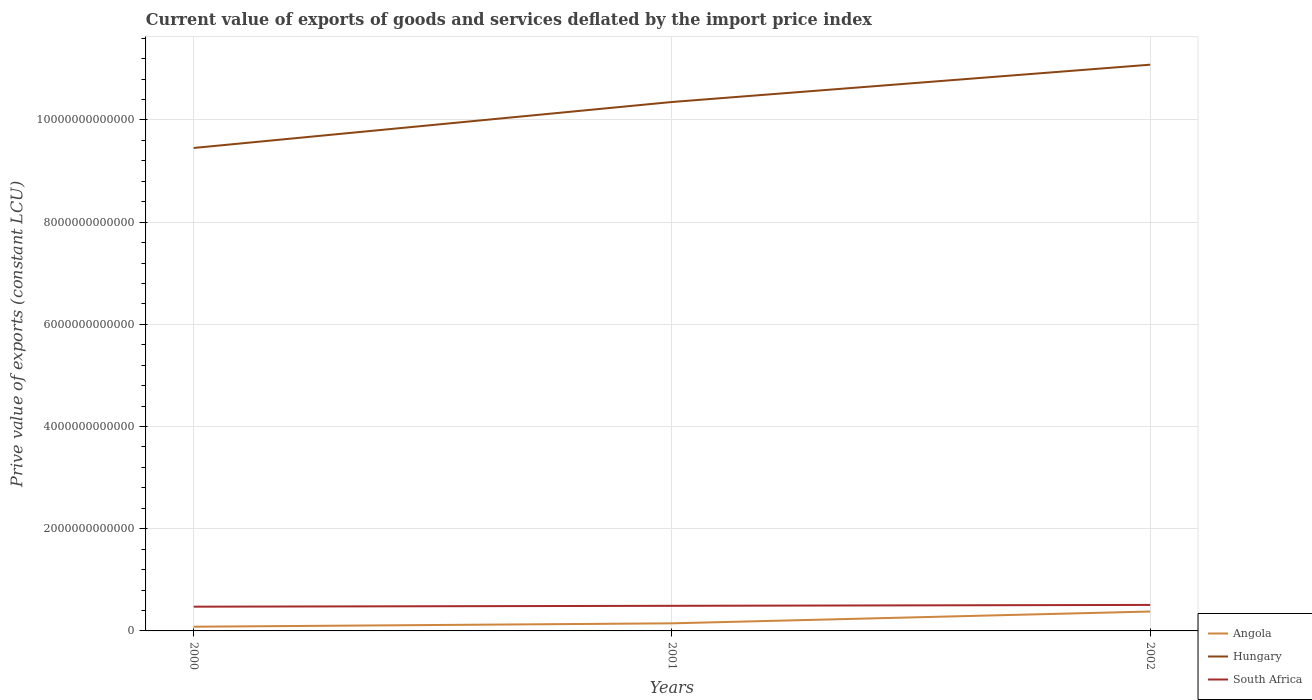Does the line corresponding to Angola intersect with the line corresponding to South Africa?
Your answer should be compact. No. Is the number of lines equal to the number of legend labels?
Give a very brief answer. Yes. Across all years, what is the maximum prive value of exports in Angola?
Your response must be concise. 8.22e+1. In which year was the prive value of exports in Hungary maximum?
Offer a very short reply. 2000. What is the total prive value of exports in Hungary in the graph?
Your answer should be very brief. -7.30e+11. What is the difference between the highest and the second highest prive value of exports in Angola?
Your answer should be compact. 2.98e+11. What is the difference between the highest and the lowest prive value of exports in Hungary?
Provide a succinct answer. 2. Is the prive value of exports in South Africa strictly greater than the prive value of exports in Hungary over the years?
Your response must be concise. Yes. How many lines are there?
Make the answer very short. 3. How many years are there in the graph?
Keep it short and to the point. 3. What is the difference between two consecutive major ticks on the Y-axis?
Give a very brief answer. 2.00e+12. Are the values on the major ticks of Y-axis written in scientific E-notation?
Your answer should be compact. No. Does the graph contain grids?
Offer a very short reply. Yes. Where does the legend appear in the graph?
Your answer should be very brief. Bottom right. How are the legend labels stacked?
Your response must be concise. Vertical. What is the title of the graph?
Your answer should be very brief. Current value of exports of goods and services deflated by the import price index. Does "Jordan" appear as one of the legend labels in the graph?
Your response must be concise. No. What is the label or title of the Y-axis?
Make the answer very short. Prive value of exports (constant LCU). What is the Prive value of exports (constant LCU) of Angola in 2000?
Your response must be concise. 8.22e+1. What is the Prive value of exports (constant LCU) in Hungary in 2000?
Make the answer very short. 9.45e+12. What is the Prive value of exports (constant LCU) in South Africa in 2000?
Make the answer very short. 4.75e+11. What is the Prive value of exports (constant LCU) in Angola in 2001?
Offer a very short reply. 1.49e+11. What is the Prive value of exports (constant LCU) in Hungary in 2001?
Give a very brief answer. 1.04e+13. What is the Prive value of exports (constant LCU) in South Africa in 2001?
Provide a succinct answer. 4.91e+11. What is the Prive value of exports (constant LCU) in Angola in 2002?
Offer a terse response. 3.80e+11. What is the Prive value of exports (constant LCU) in Hungary in 2002?
Ensure brevity in your answer.  1.11e+13. What is the Prive value of exports (constant LCU) of South Africa in 2002?
Your answer should be very brief. 5.09e+11. Across all years, what is the maximum Prive value of exports (constant LCU) in Angola?
Ensure brevity in your answer.  3.80e+11. Across all years, what is the maximum Prive value of exports (constant LCU) in Hungary?
Your answer should be compact. 1.11e+13. Across all years, what is the maximum Prive value of exports (constant LCU) in South Africa?
Your answer should be compact. 5.09e+11. Across all years, what is the minimum Prive value of exports (constant LCU) of Angola?
Your answer should be very brief. 8.22e+1. Across all years, what is the minimum Prive value of exports (constant LCU) in Hungary?
Offer a very short reply. 9.45e+12. Across all years, what is the minimum Prive value of exports (constant LCU) of South Africa?
Keep it short and to the point. 4.75e+11. What is the total Prive value of exports (constant LCU) of Angola in the graph?
Provide a short and direct response. 6.11e+11. What is the total Prive value of exports (constant LCU) of Hungary in the graph?
Provide a succinct answer. 3.09e+13. What is the total Prive value of exports (constant LCU) of South Africa in the graph?
Keep it short and to the point. 1.47e+12. What is the difference between the Prive value of exports (constant LCU) in Angola in 2000 and that in 2001?
Provide a short and direct response. -6.64e+1. What is the difference between the Prive value of exports (constant LCU) in Hungary in 2000 and that in 2001?
Your answer should be very brief. -9.00e+11. What is the difference between the Prive value of exports (constant LCU) in South Africa in 2000 and that in 2001?
Make the answer very short. -1.68e+1. What is the difference between the Prive value of exports (constant LCU) in Angola in 2000 and that in 2002?
Your answer should be compact. -2.98e+11. What is the difference between the Prive value of exports (constant LCU) in Hungary in 2000 and that in 2002?
Give a very brief answer. -1.63e+12. What is the difference between the Prive value of exports (constant LCU) of South Africa in 2000 and that in 2002?
Ensure brevity in your answer.  -3.42e+1. What is the difference between the Prive value of exports (constant LCU) of Angola in 2001 and that in 2002?
Ensure brevity in your answer.  -2.31e+11. What is the difference between the Prive value of exports (constant LCU) of Hungary in 2001 and that in 2002?
Provide a succinct answer. -7.30e+11. What is the difference between the Prive value of exports (constant LCU) in South Africa in 2001 and that in 2002?
Offer a very short reply. -1.75e+1. What is the difference between the Prive value of exports (constant LCU) of Angola in 2000 and the Prive value of exports (constant LCU) of Hungary in 2001?
Give a very brief answer. -1.03e+13. What is the difference between the Prive value of exports (constant LCU) in Angola in 2000 and the Prive value of exports (constant LCU) in South Africa in 2001?
Make the answer very short. -4.09e+11. What is the difference between the Prive value of exports (constant LCU) of Hungary in 2000 and the Prive value of exports (constant LCU) of South Africa in 2001?
Offer a very short reply. 8.96e+12. What is the difference between the Prive value of exports (constant LCU) of Angola in 2000 and the Prive value of exports (constant LCU) of Hungary in 2002?
Ensure brevity in your answer.  -1.10e+13. What is the difference between the Prive value of exports (constant LCU) in Angola in 2000 and the Prive value of exports (constant LCU) in South Africa in 2002?
Make the answer very short. -4.27e+11. What is the difference between the Prive value of exports (constant LCU) of Hungary in 2000 and the Prive value of exports (constant LCU) of South Africa in 2002?
Make the answer very short. 8.94e+12. What is the difference between the Prive value of exports (constant LCU) in Angola in 2001 and the Prive value of exports (constant LCU) in Hungary in 2002?
Make the answer very short. -1.09e+13. What is the difference between the Prive value of exports (constant LCU) of Angola in 2001 and the Prive value of exports (constant LCU) of South Africa in 2002?
Offer a very short reply. -3.60e+11. What is the difference between the Prive value of exports (constant LCU) of Hungary in 2001 and the Prive value of exports (constant LCU) of South Africa in 2002?
Offer a very short reply. 9.84e+12. What is the average Prive value of exports (constant LCU) in Angola per year?
Provide a short and direct response. 2.04e+11. What is the average Prive value of exports (constant LCU) in Hungary per year?
Your response must be concise. 1.03e+13. What is the average Prive value of exports (constant LCU) of South Africa per year?
Provide a succinct answer. 4.92e+11. In the year 2000, what is the difference between the Prive value of exports (constant LCU) of Angola and Prive value of exports (constant LCU) of Hungary?
Your answer should be compact. -9.37e+12. In the year 2000, what is the difference between the Prive value of exports (constant LCU) in Angola and Prive value of exports (constant LCU) in South Africa?
Provide a short and direct response. -3.92e+11. In the year 2000, what is the difference between the Prive value of exports (constant LCU) of Hungary and Prive value of exports (constant LCU) of South Africa?
Provide a succinct answer. 8.98e+12. In the year 2001, what is the difference between the Prive value of exports (constant LCU) of Angola and Prive value of exports (constant LCU) of Hungary?
Make the answer very short. -1.02e+13. In the year 2001, what is the difference between the Prive value of exports (constant LCU) of Angola and Prive value of exports (constant LCU) of South Africa?
Keep it short and to the point. -3.43e+11. In the year 2001, what is the difference between the Prive value of exports (constant LCU) of Hungary and Prive value of exports (constant LCU) of South Africa?
Keep it short and to the point. 9.86e+12. In the year 2002, what is the difference between the Prive value of exports (constant LCU) of Angola and Prive value of exports (constant LCU) of Hungary?
Keep it short and to the point. -1.07e+13. In the year 2002, what is the difference between the Prive value of exports (constant LCU) in Angola and Prive value of exports (constant LCU) in South Africa?
Your response must be concise. -1.29e+11. In the year 2002, what is the difference between the Prive value of exports (constant LCU) in Hungary and Prive value of exports (constant LCU) in South Africa?
Keep it short and to the point. 1.06e+13. What is the ratio of the Prive value of exports (constant LCU) in Angola in 2000 to that in 2001?
Provide a short and direct response. 0.55. What is the ratio of the Prive value of exports (constant LCU) of Hungary in 2000 to that in 2001?
Ensure brevity in your answer.  0.91. What is the ratio of the Prive value of exports (constant LCU) in South Africa in 2000 to that in 2001?
Keep it short and to the point. 0.97. What is the ratio of the Prive value of exports (constant LCU) of Angola in 2000 to that in 2002?
Ensure brevity in your answer.  0.22. What is the ratio of the Prive value of exports (constant LCU) in Hungary in 2000 to that in 2002?
Make the answer very short. 0.85. What is the ratio of the Prive value of exports (constant LCU) of South Africa in 2000 to that in 2002?
Offer a terse response. 0.93. What is the ratio of the Prive value of exports (constant LCU) in Angola in 2001 to that in 2002?
Your response must be concise. 0.39. What is the ratio of the Prive value of exports (constant LCU) in Hungary in 2001 to that in 2002?
Ensure brevity in your answer.  0.93. What is the ratio of the Prive value of exports (constant LCU) in South Africa in 2001 to that in 2002?
Your answer should be very brief. 0.97. What is the difference between the highest and the second highest Prive value of exports (constant LCU) in Angola?
Your answer should be compact. 2.31e+11. What is the difference between the highest and the second highest Prive value of exports (constant LCU) of Hungary?
Provide a short and direct response. 7.30e+11. What is the difference between the highest and the second highest Prive value of exports (constant LCU) of South Africa?
Make the answer very short. 1.75e+1. What is the difference between the highest and the lowest Prive value of exports (constant LCU) of Angola?
Provide a succinct answer. 2.98e+11. What is the difference between the highest and the lowest Prive value of exports (constant LCU) in Hungary?
Your answer should be very brief. 1.63e+12. What is the difference between the highest and the lowest Prive value of exports (constant LCU) in South Africa?
Your response must be concise. 3.42e+1. 